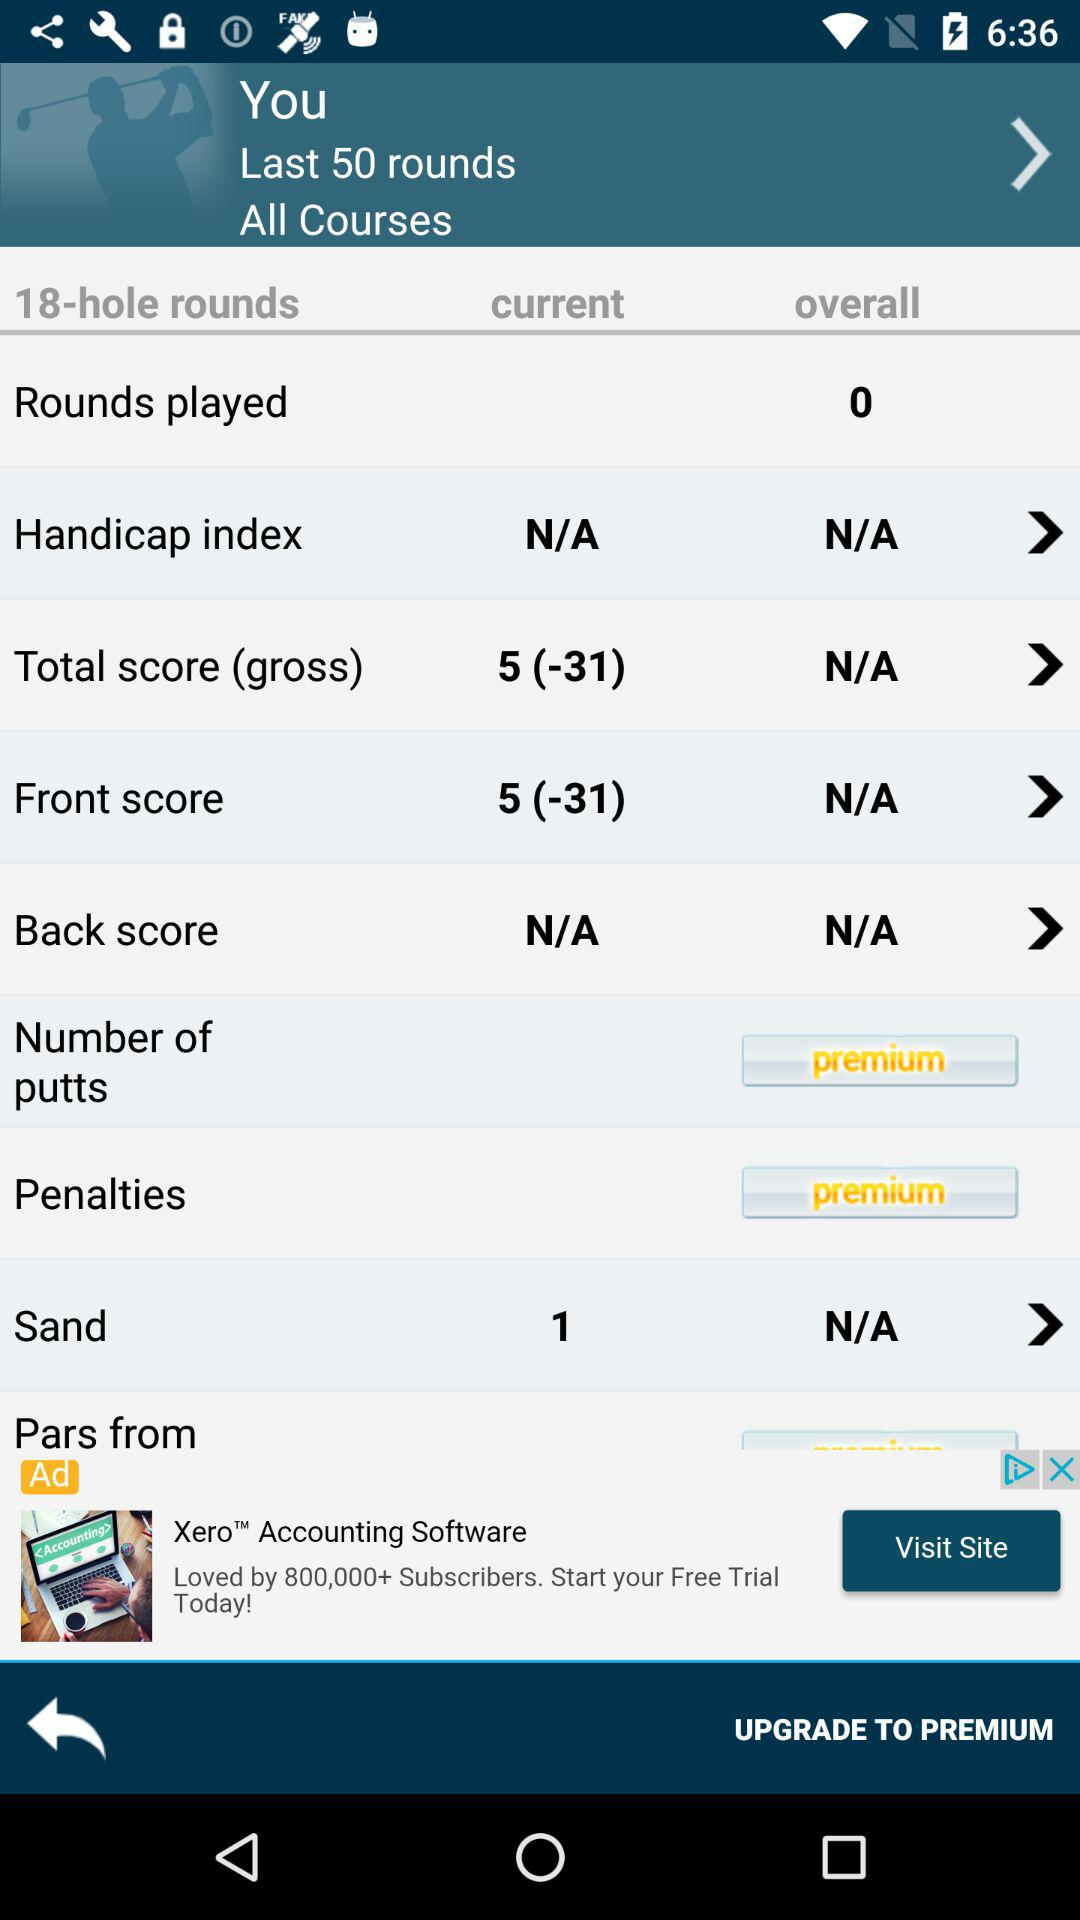What is the number of shots played from the sand for the current hole? The number of shots played from the sand for the current hole is 1. 